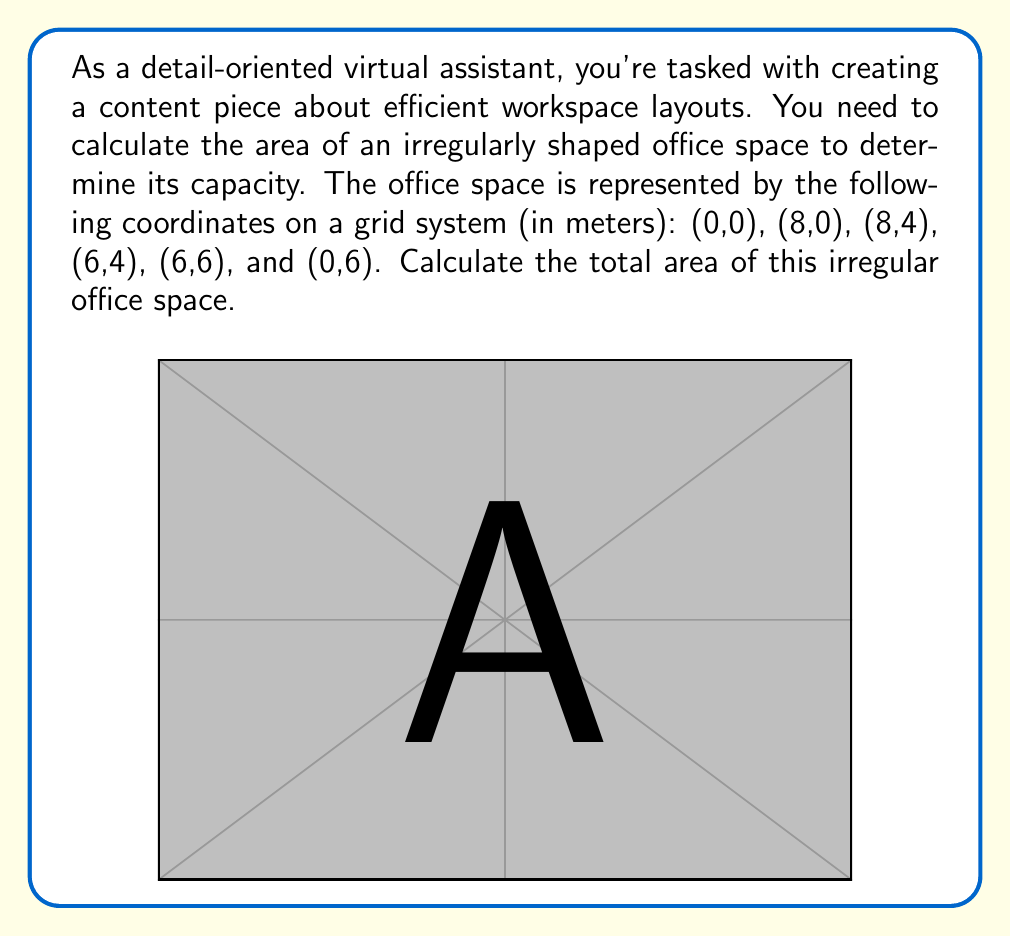Show me your answer to this math problem. To calculate the area of this irregular shape, we can use the Shoelace formula (also known as the surveyor's formula). This method works for any polygon given its vertices.

The formula is:

$$ A = \frac{1}{2}|\sum_{i=1}^{n-1} (x_iy_{i+1} - x_{i+1}y_i) + (x_ny_1 - x_1y_n)| $$

Where $(x_i, y_i)$ are the coordinates of the $i$-th vertex.

Let's apply this to our coordinates:

1) First, let's list our coordinates in order:
   $(0,0)$, $(8,0)$, $(8,4)$, $(6,4)$, $(6,6)$, $(0,6)$

2) Now, let's calculate each term in the sum:

   $(0 \cdot 0) - (8 \cdot 0) = 0$
   $(8 \cdot 4) - (8 \cdot 0) = 32$
   $(8 \cdot 4) - (6 \cdot 4) = 8$
   $(6 \cdot 6) - (6 \cdot 4) = 12$
   $(6 \cdot 6) - (0 \cdot 6) = 36$
   $(0 \cdot 0) - (0 \cdot 6) = 0$

3) Sum these values:

   $0 + 32 + 8 + 12 + 36 + 0 = 88$

4) Multiply by $\frac{1}{2}$:

   $\frac{1}{2} \cdot 88 = 44$

Therefore, the area of the office space is 44 square meters.
Answer: The area of the irregular office space is 44 m². 